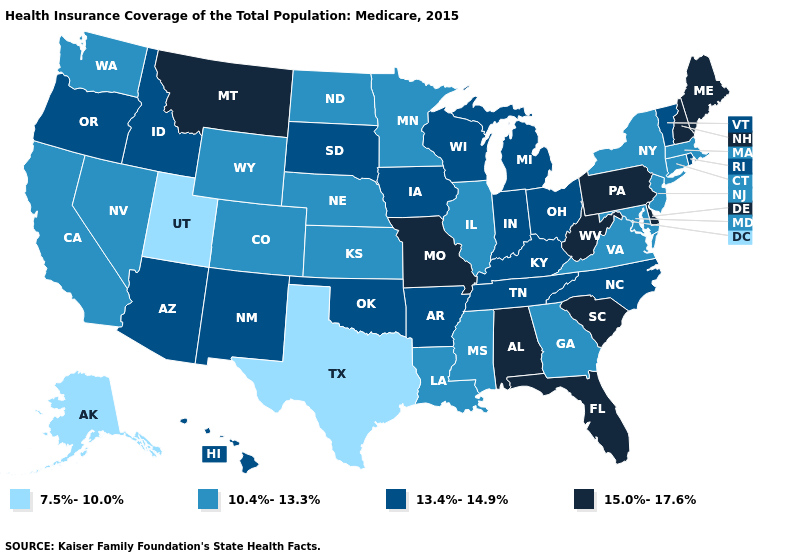How many symbols are there in the legend?
Give a very brief answer. 4. What is the value of Tennessee?
Be succinct. 13.4%-14.9%. Which states have the lowest value in the USA?
Concise answer only. Alaska, Texas, Utah. Does the first symbol in the legend represent the smallest category?
Quick response, please. Yes. What is the value of Maine?
Answer briefly. 15.0%-17.6%. Name the states that have a value in the range 13.4%-14.9%?
Concise answer only. Arizona, Arkansas, Hawaii, Idaho, Indiana, Iowa, Kentucky, Michigan, New Mexico, North Carolina, Ohio, Oklahoma, Oregon, Rhode Island, South Dakota, Tennessee, Vermont, Wisconsin. Name the states that have a value in the range 10.4%-13.3%?
Be succinct. California, Colorado, Connecticut, Georgia, Illinois, Kansas, Louisiana, Maryland, Massachusetts, Minnesota, Mississippi, Nebraska, Nevada, New Jersey, New York, North Dakota, Virginia, Washington, Wyoming. Does Idaho have the same value as Delaware?
Keep it brief. No. Does the first symbol in the legend represent the smallest category?
Quick response, please. Yes. Does Missouri have the same value as West Virginia?
Keep it brief. Yes. What is the value of Missouri?
Be succinct. 15.0%-17.6%. Does New Jersey have a lower value than Texas?
Answer briefly. No. Does the map have missing data?
Answer briefly. No. Which states hav the highest value in the MidWest?
Write a very short answer. Missouri. 